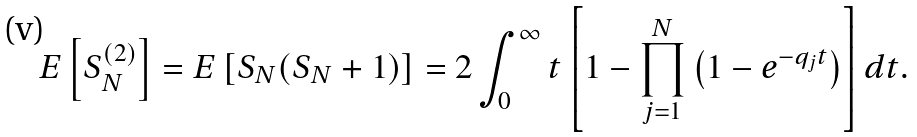<formula> <loc_0><loc_0><loc_500><loc_500>E \left [ S _ { N } ^ { ( 2 ) } \right ] = E \left [ S _ { N } ( S _ { N } + 1 ) \right ] = 2 \int _ { 0 } ^ { \infty } t \left [ 1 - \prod _ { j = 1 } ^ { N } \left ( 1 - e ^ { - q _ { j } t } \right ) \right ] d t .</formula> 